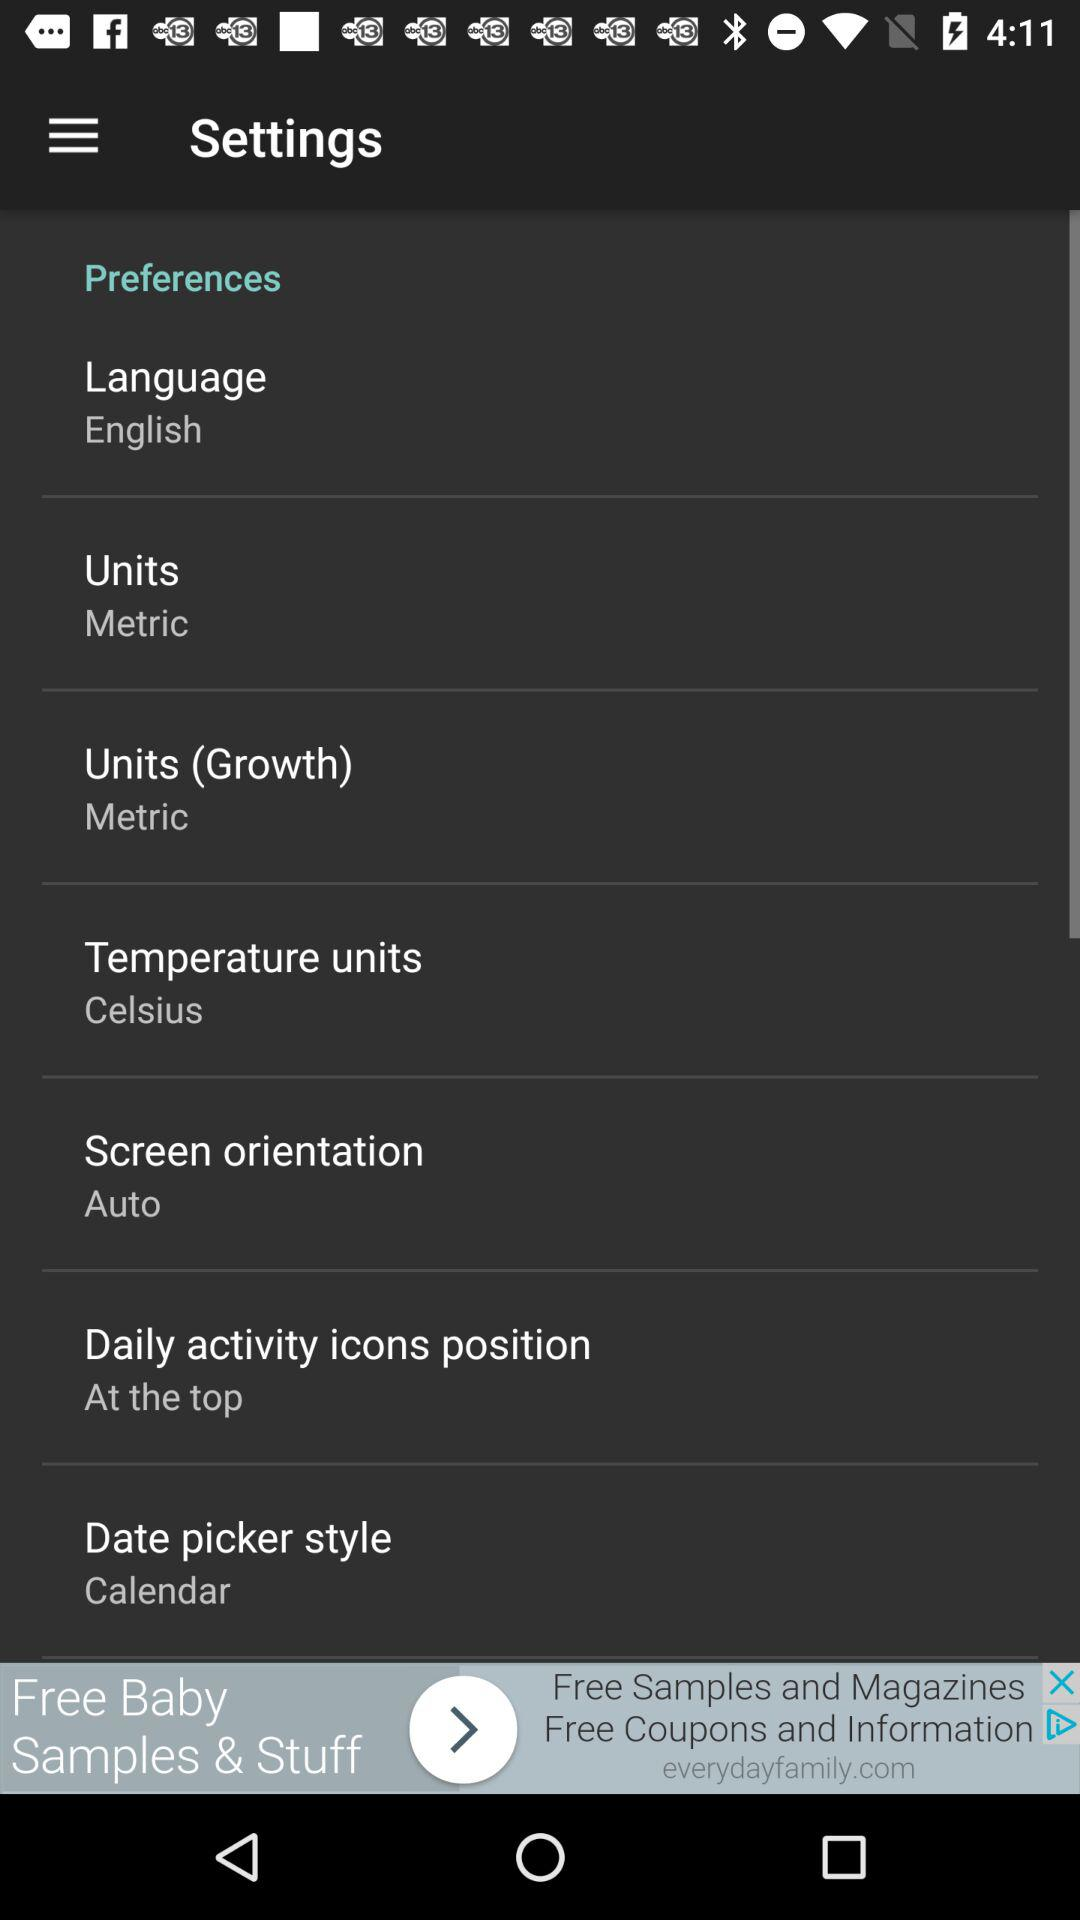Who is this application powered by?
When the provided information is insufficient, respond with <no answer>. <no answer> 